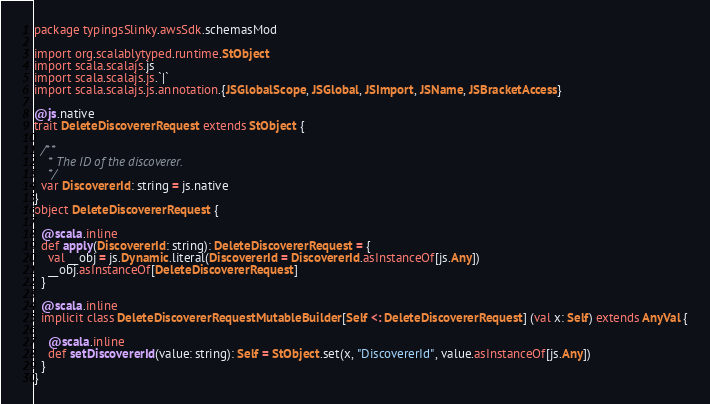Convert code to text. <code><loc_0><loc_0><loc_500><loc_500><_Scala_>package typingsSlinky.awsSdk.schemasMod

import org.scalablytyped.runtime.StObject
import scala.scalajs.js
import scala.scalajs.js.`|`
import scala.scalajs.js.annotation.{JSGlobalScope, JSGlobal, JSImport, JSName, JSBracketAccess}

@js.native
trait DeleteDiscovererRequest extends StObject {
  
  /**
    * The ID of the discoverer.
    */
  var DiscovererId: string = js.native
}
object DeleteDiscovererRequest {
  
  @scala.inline
  def apply(DiscovererId: string): DeleteDiscovererRequest = {
    val __obj = js.Dynamic.literal(DiscovererId = DiscovererId.asInstanceOf[js.Any])
    __obj.asInstanceOf[DeleteDiscovererRequest]
  }
  
  @scala.inline
  implicit class DeleteDiscovererRequestMutableBuilder[Self <: DeleteDiscovererRequest] (val x: Self) extends AnyVal {
    
    @scala.inline
    def setDiscovererId(value: string): Self = StObject.set(x, "DiscovererId", value.asInstanceOf[js.Any])
  }
}
</code> 